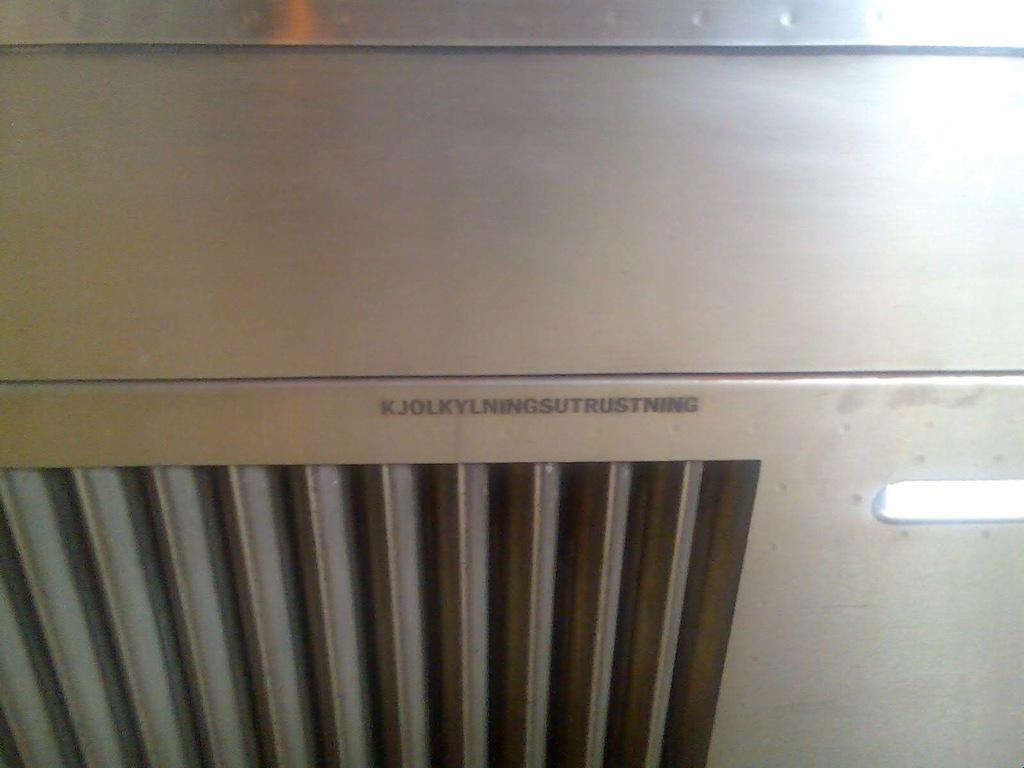<image>
Offer a succinct explanation of the picture presented. Furnace with a name starting with a k. 